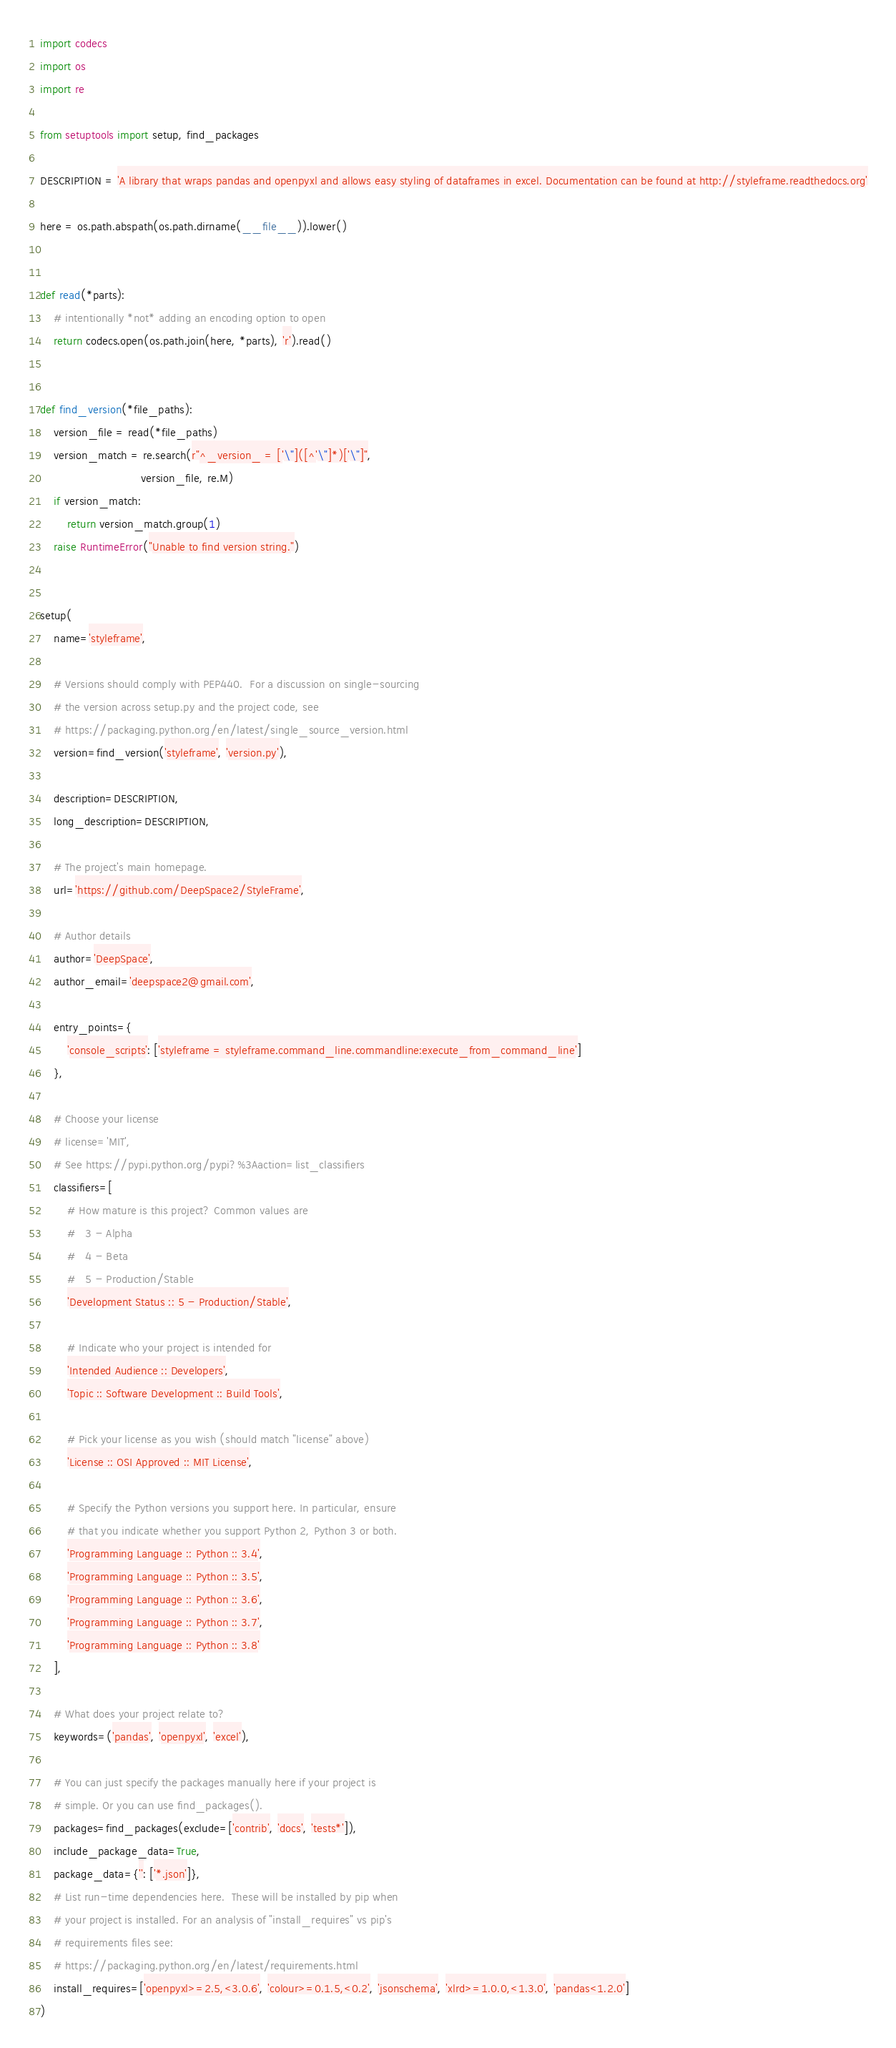<code> <loc_0><loc_0><loc_500><loc_500><_Python_>import codecs
import os
import re

from setuptools import setup, find_packages

DESCRIPTION = 'A library that wraps pandas and openpyxl and allows easy styling of dataframes in excel. Documentation can be found at http://styleframe.readthedocs.org'

here = os.path.abspath(os.path.dirname(__file__)).lower()


def read(*parts):
    # intentionally *not* adding an encoding option to open
    return codecs.open(os.path.join(here, *parts), 'r').read()


def find_version(*file_paths):
    version_file = read(*file_paths)
    version_match = re.search(r"^_version_ = ['\"]([^'\"]*)['\"]",
                              version_file, re.M)
    if version_match:
        return version_match.group(1)
    raise RuntimeError("Unable to find version string.")


setup(
    name='styleframe',

    # Versions should comply with PEP440.  For a discussion on single-sourcing
    # the version across setup.py and the project code, see
    # https://packaging.python.org/en/latest/single_source_version.html
    version=find_version('styleframe', 'version.py'),

    description=DESCRIPTION,
    long_description=DESCRIPTION,

    # The project's main homepage.
    url='https://github.com/DeepSpace2/StyleFrame',

    # Author details
    author='DeepSpace',
    author_email='deepspace2@gmail.com',

    entry_points={
        'console_scripts': ['styleframe = styleframe.command_line.commandline:execute_from_command_line']
    },

    # Choose your license
    # license='MIT',
    # See https://pypi.python.org/pypi?%3Aaction=list_classifiers
    classifiers=[
        # How mature is this project? Common values are
        #   3 - Alpha
        #   4 - Beta
        #   5 - Production/Stable
        'Development Status :: 5 - Production/Stable',

        # Indicate who your project is intended for
        'Intended Audience :: Developers',
        'Topic :: Software Development :: Build Tools',

        # Pick your license as you wish (should match "license" above)
        'License :: OSI Approved :: MIT License',

        # Specify the Python versions you support here. In particular, ensure
        # that you indicate whether you support Python 2, Python 3 or both.
        'Programming Language :: Python :: 3.4',
        'Programming Language :: Python :: 3.5',
        'Programming Language :: Python :: 3.6',
        'Programming Language :: Python :: 3.7',
        'Programming Language :: Python :: 3.8'
    ],

    # What does your project relate to?
    keywords=('pandas', 'openpyxl', 'excel'),

    # You can just specify the packages manually here if your project is
    # simple. Or you can use find_packages().
    packages=find_packages(exclude=['contrib', 'docs', 'tests*']),
    include_package_data=True,
    package_data={'': ['*.json']},
    # List run-time dependencies here.  These will be installed by pip when
    # your project is installed. For an analysis of "install_requires" vs pip's
    # requirements files see:
    # https://packaging.python.org/en/latest/requirements.html
    install_requires=['openpyxl>=2.5,<3.0.6', 'colour>=0.1.5,<0.2', 'jsonschema', 'xlrd>=1.0.0,<1.3.0', 'pandas<1.2.0']
)
</code> 